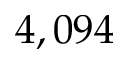<formula> <loc_0><loc_0><loc_500><loc_500>4 , 0 9 4</formula> 